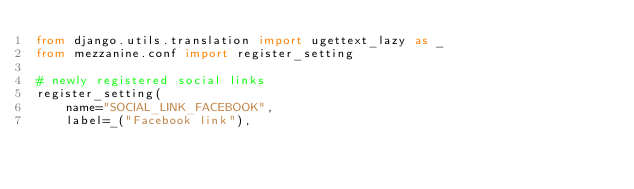Convert code to text. <code><loc_0><loc_0><loc_500><loc_500><_Python_>from django.utils.translation import ugettext_lazy as _
from mezzanine.conf import register_setting

# newly registered social links
register_setting(
    name="SOCIAL_LINK_FACEBOOK",
    label=_("Facebook link"),</code> 